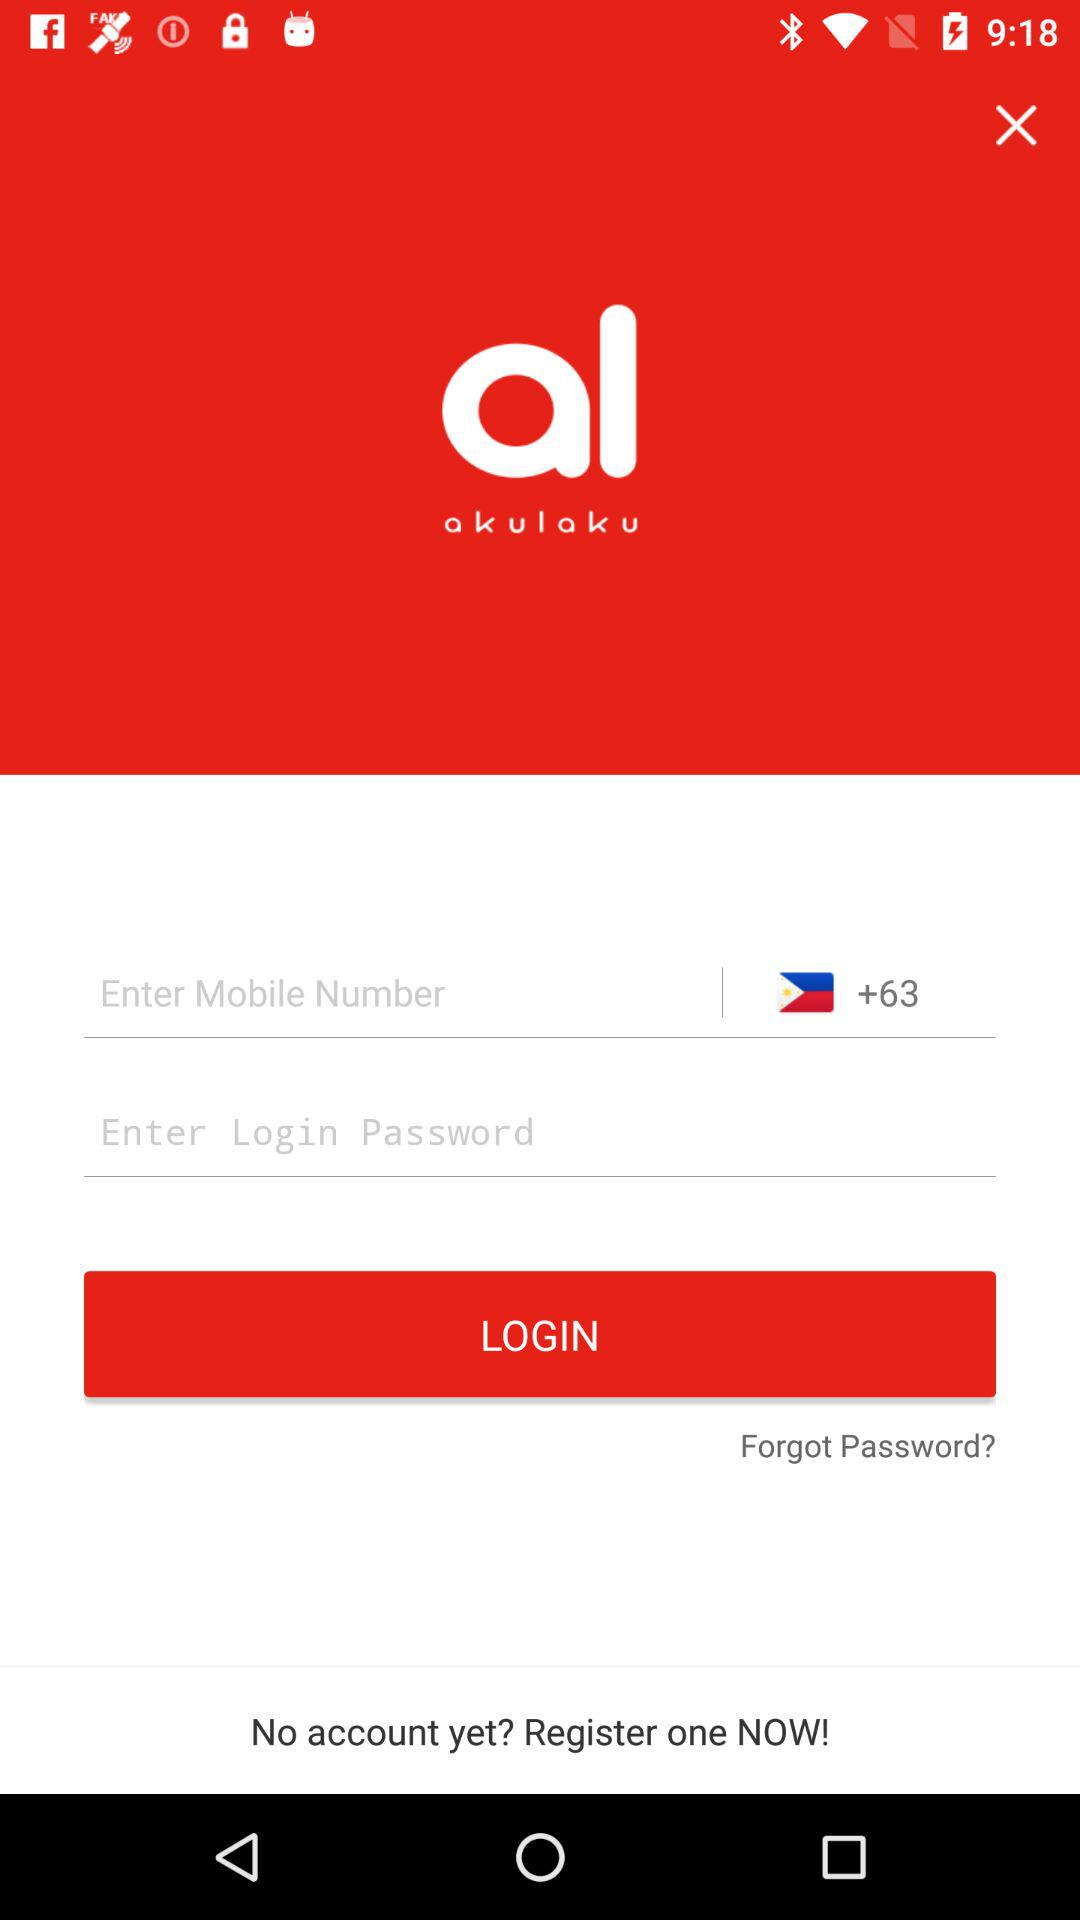What is the name of the application? The name of the application is "akulaku". 